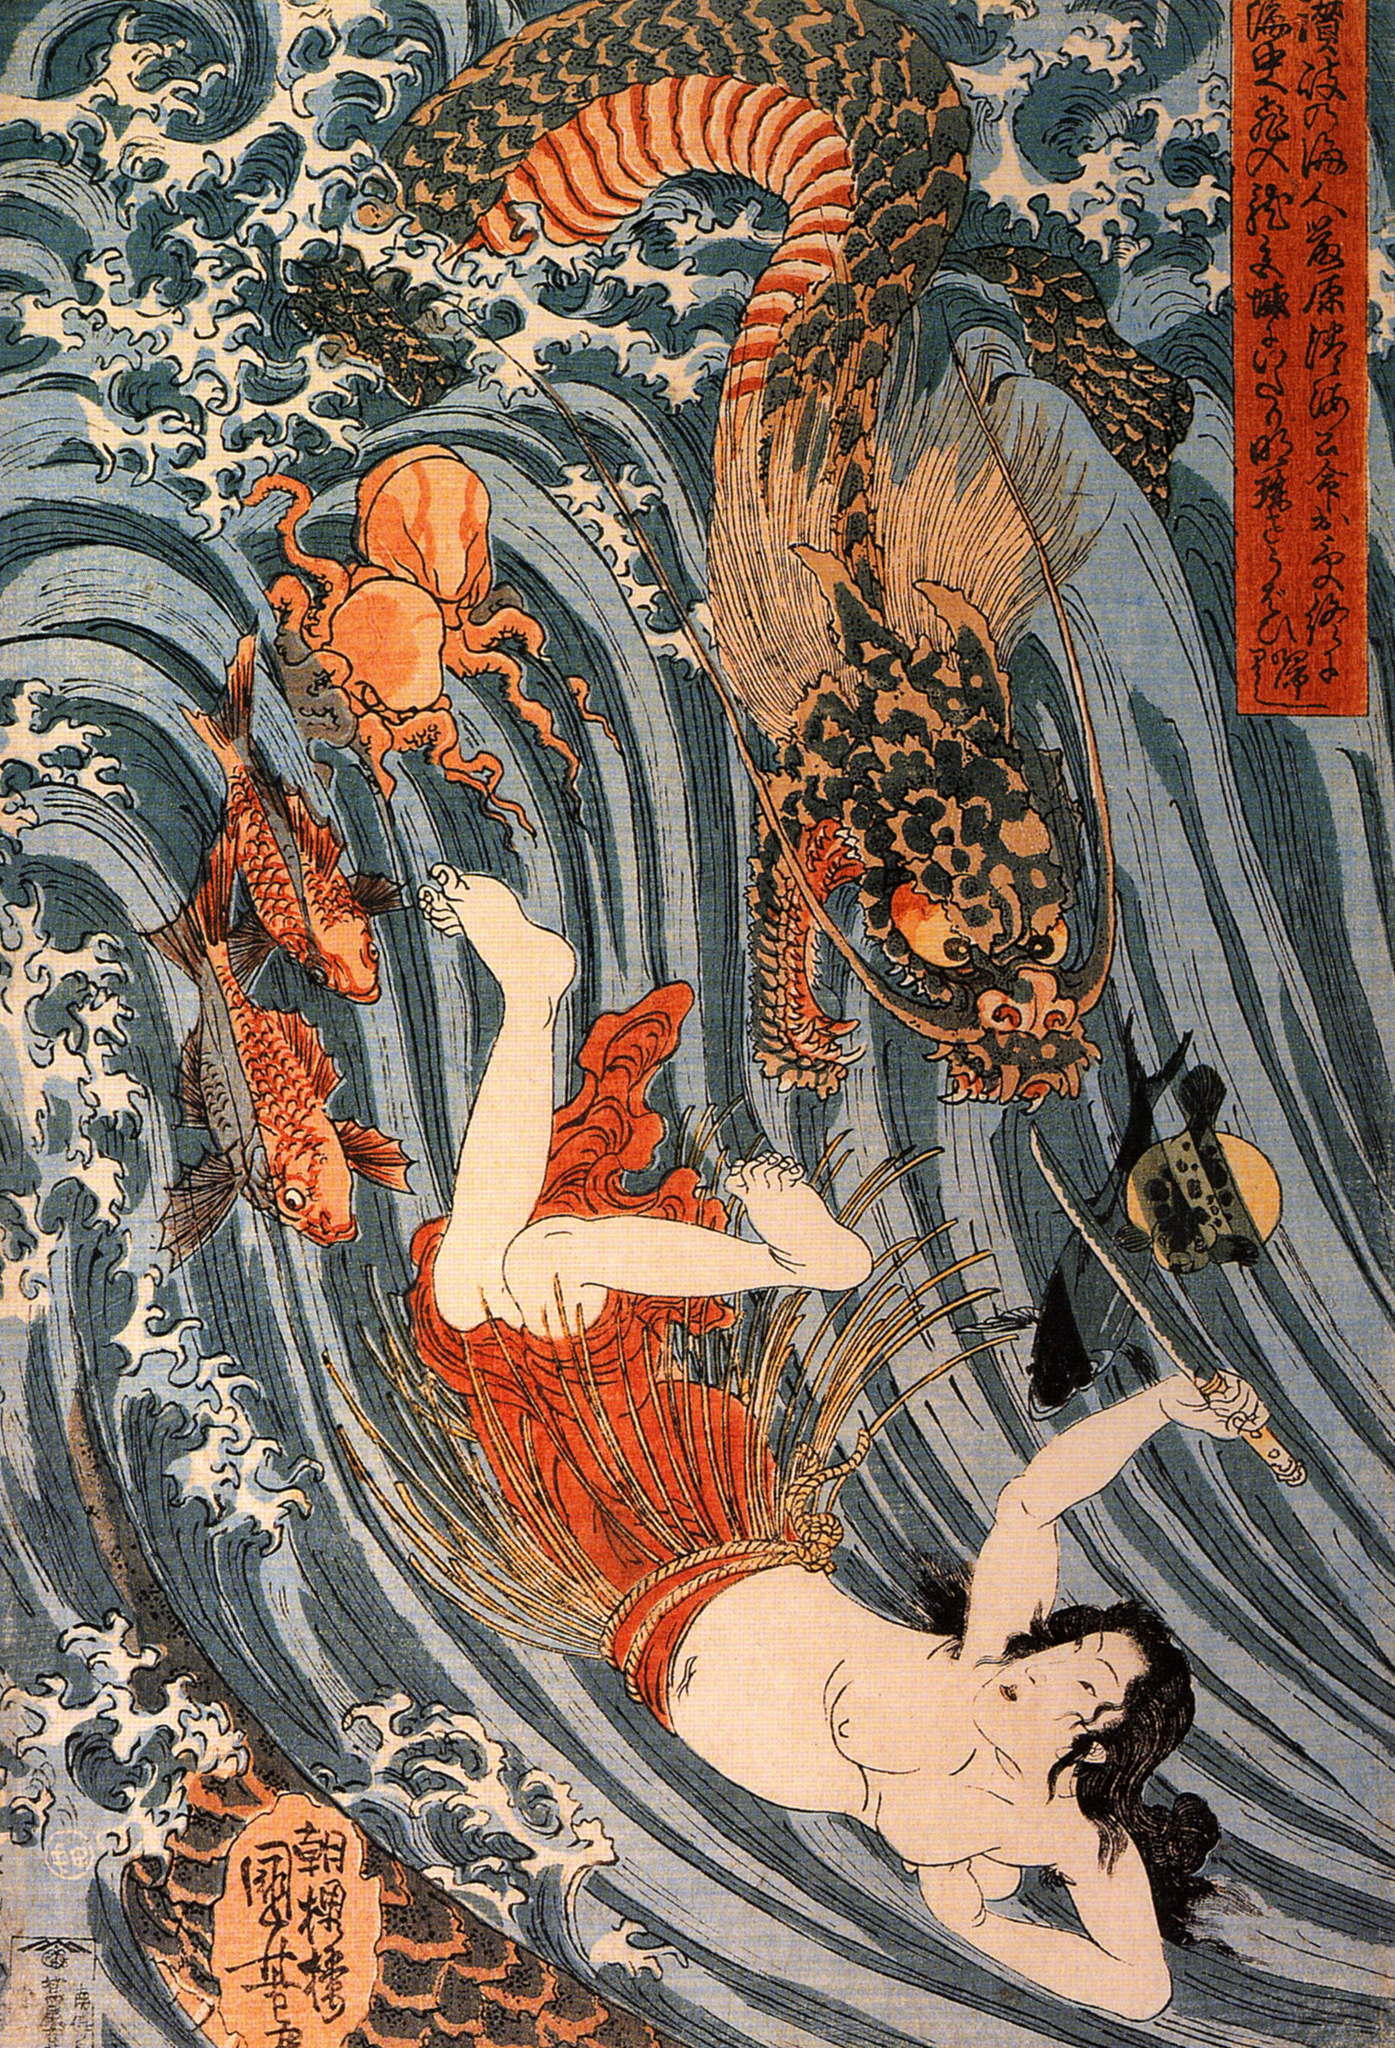Can you explain the significance of the dragon in this artwork? The dragon in this artwork, rendered with vibrant orange and black hues, symbolizes strength, power, and divine protection in many Asian cultures, particularly in Japan. Its presence intertwined with human characters often suggests themes of spiritual guardianship or metaphysical influence. In this scene, the dragon’s menacing posture juxtaposed with its protective demeanor around the woman could be interpreted as a guardian spirit's dual nature. 